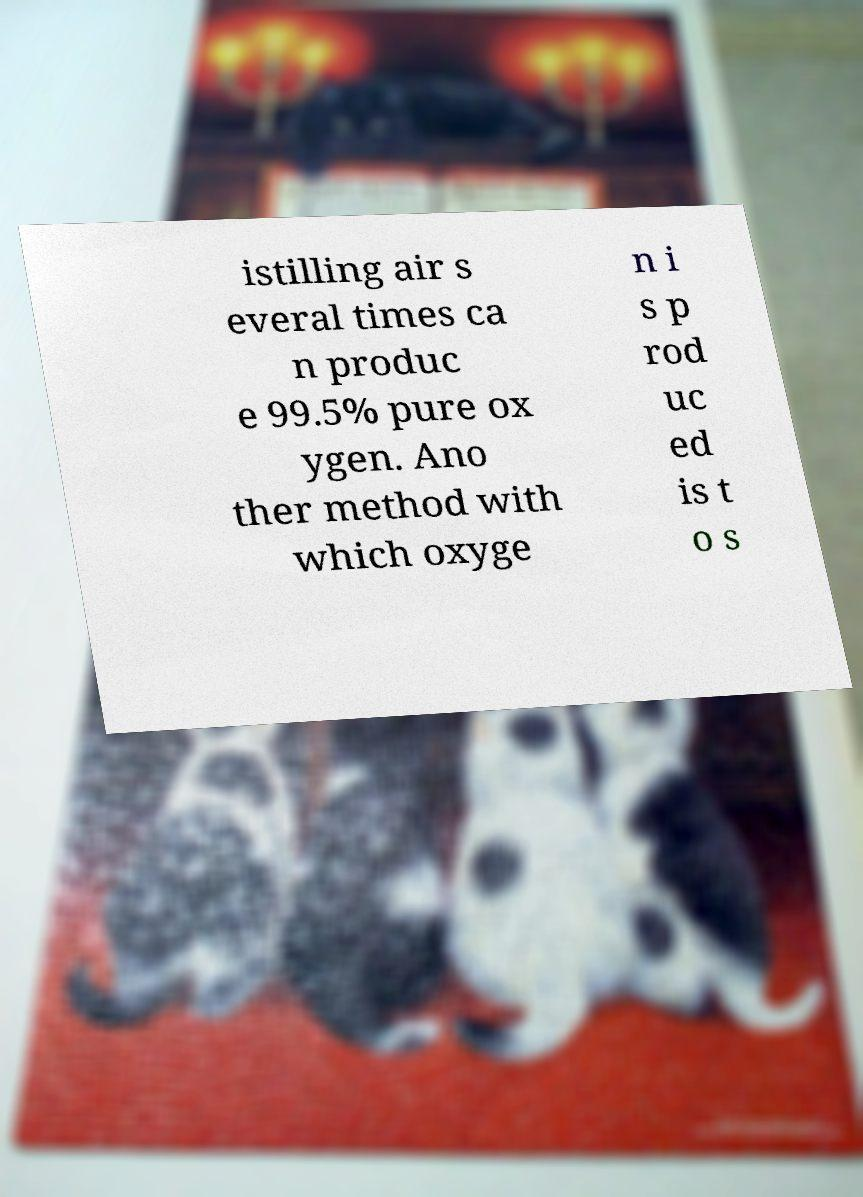Can you read and provide the text displayed in the image?This photo seems to have some interesting text. Can you extract and type it out for me? istilling air s everal times ca n produc e 99.5% pure ox ygen. Ano ther method with which oxyge n i s p rod uc ed is t o s 